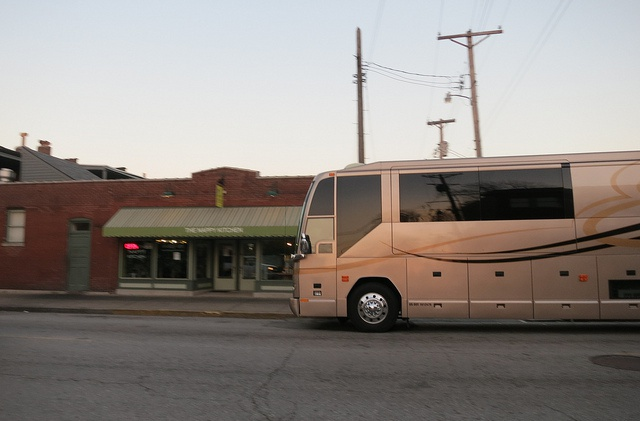Describe the objects in this image and their specific colors. I can see bus in lightgray, gray, black, and maroon tones in this image. 